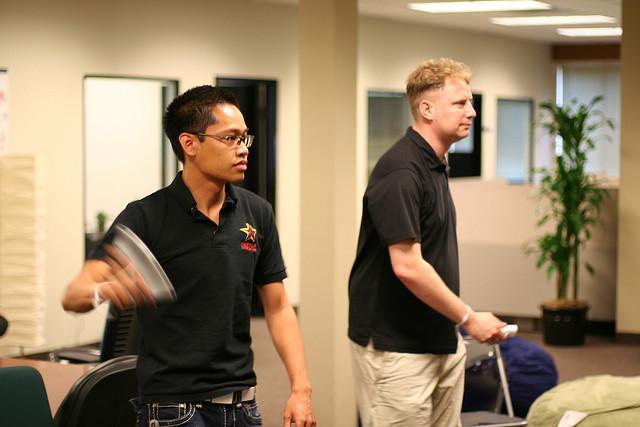What activity are the men involved in?
Select the accurate answer and provide explanation: 'Answer: answer
Rationale: rationale.'
Options: Gaming, gambling, sports, writing. Answer: gaming.
Rationale: The men are holding wii-motes. wii is a game console. 